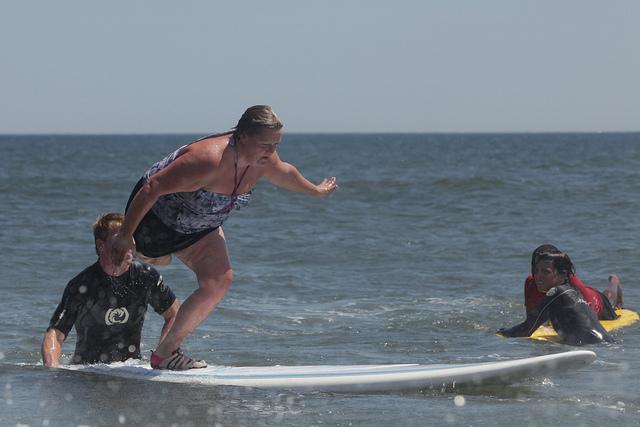Is the woman going to be wet?
Short answer required. Yes. What color is the girl's board?
Quick response, please. White. How many people are in the water?
Concise answer only. 2. Is the surfer about to fall?
Keep it brief. Yes. How many people are seen?
Be succinct. 4. Are there instructors in this image?
Write a very short answer. Yes. 